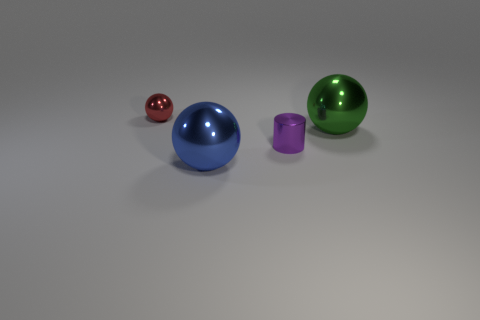Subtract all blue shiny spheres. How many spheres are left? 2 Subtract all green balls. How many balls are left? 2 Add 1 big red rubber things. How many objects exist? 5 Subtract all green blocks. How many red spheres are left? 1 Subtract 1 spheres. How many spheres are left? 2 Subtract all large blue shiny objects. Subtract all big green metallic spheres. How many objects are left? 2 Add 1 big blue shiny balls. How many big blue shiny balls are left? 2 Add 4 big green balls. How many big green balls exist? 5 Subtract 0 gray cylinders. How many objects are left? 4 Subtract all cylinders. How many objects are left? 3 